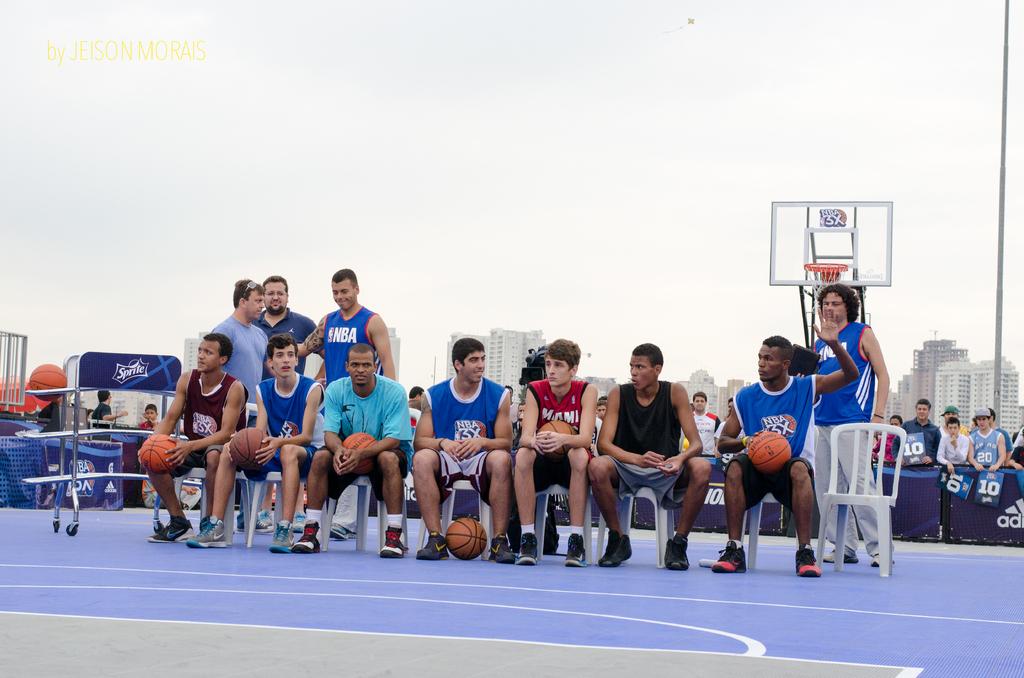What basketball association is displayed on these jerseys?
Your response must be concise. Nba. What is written on the backboard?
Your response must be concise. Nba 3x. 